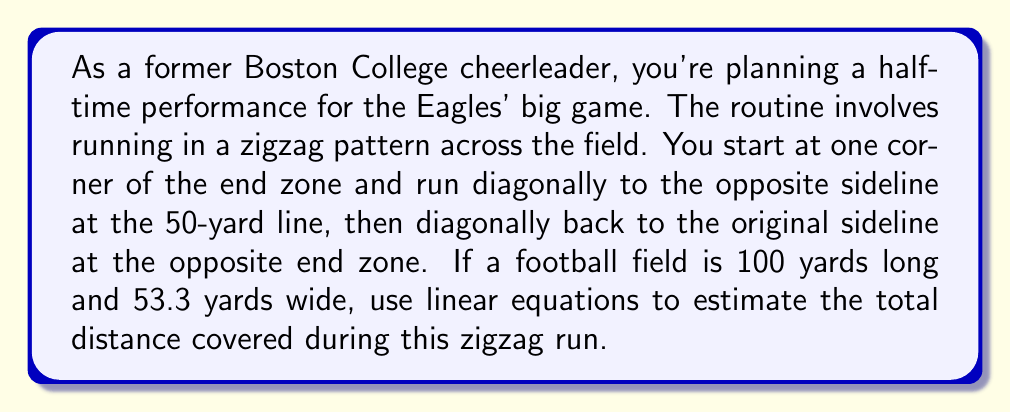Help me with this question. To solve this problem, we need to break it down into steps:

1) First, let's visualize the path as two right triangles. We can use the Pythagorean theorem to calculate the distance of each diagonal run.

2) For the first diagonal:
   - The base of the triangle is 50 yards (half the field length)
   - The height of the triangle is 53.3 yards (the field width)

3) Let's call the distance of this diagonal $d$. Using the Pythagorean theorem:

   $$d^2 = 50^2 + 53.3^2$$

4) Solving for $d$:

   $$d = \sqrt{50^2 + 53.3^2} = \sqrt{2500 + 2840.89} = \sqrt{5340.89} \approx 73.08 \text{ yards}$$

5) The second diagonal is identical to the first, so the total distance is:

   $$\text{Total distance} = 2d \approx 2 * 73.08 = 146.16 \text{ yards}$$

6) To convert yards to feet, multiply by 3:

   $$146.16 \text{ yards} * 3 = 438.48 \text{ feet}$$

Therefore, the estimated total distance covered during the halftime performance is approximately 438.48 feet.
Answer: 438.48 feet 